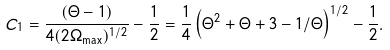<formula> <loc_0><loc_0><loc_500><loc_500>C _ { 1 } = \frac { ( \Theta - 1 ) } { 4 ( 2 \Omega _ { \max } ) ^ { 1 / 2 } } - \frac { 1 } { 2 } = \frac { 1 } { 4 } \left ( \Theta ^ { 2 } + \Theta + 3 - 1 / \Theta \right ) ^ { 1 / 2 } - \frac { 1 } { 2 } .</formula> 